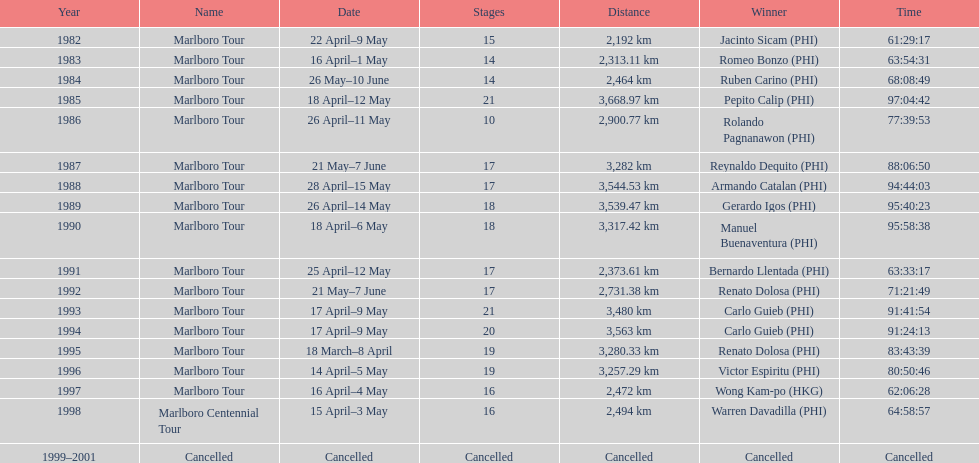What was the maximum distance journeyed for the marlboro tour? 3,668.97 km. 